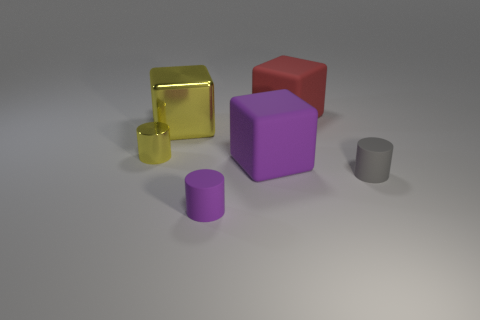There is a object that is right of the large purple matte cube and in front of the red rubber cube; what is its size?
Give a very brief answer. Small. Does the metal cylinder have the same color as the large cube that is on the left side of the purple rubber block?
Keep it short and to the point. Yes. What is the material of the red cube?
Provide a succinct answer. Rubber. Is the number of rubber blocks in front of the red matte object greater than the number of large brown rubber cubes?
Your response must be concise. Yes. Do the gray object and the tiny yellow object on the left side of the small purple matte object have the same shape?
Your response must be concise. Yes. There is a small shiny object that is the same color as the shiny cube; what is its shape?
Your answer should be compact. Cylinder. How many tiny gray matte cylinders are on the right side of the small cylinder that is left of the tiny rubber cylinder that is left of the purple rubber block?
Offer a terse response. 1. There is a metallic cylinder that is the same size as the gray thing; what is its color?
Your answer should be very brief. Yellow. There is a cylinder on the right side of the rubber block on the right side of the purple block; what is its size?
Provide a succinct answer. Small. The cube that is the same color as the tiny metallic cylinder is what size?
Keep it short and to the point. Large. 